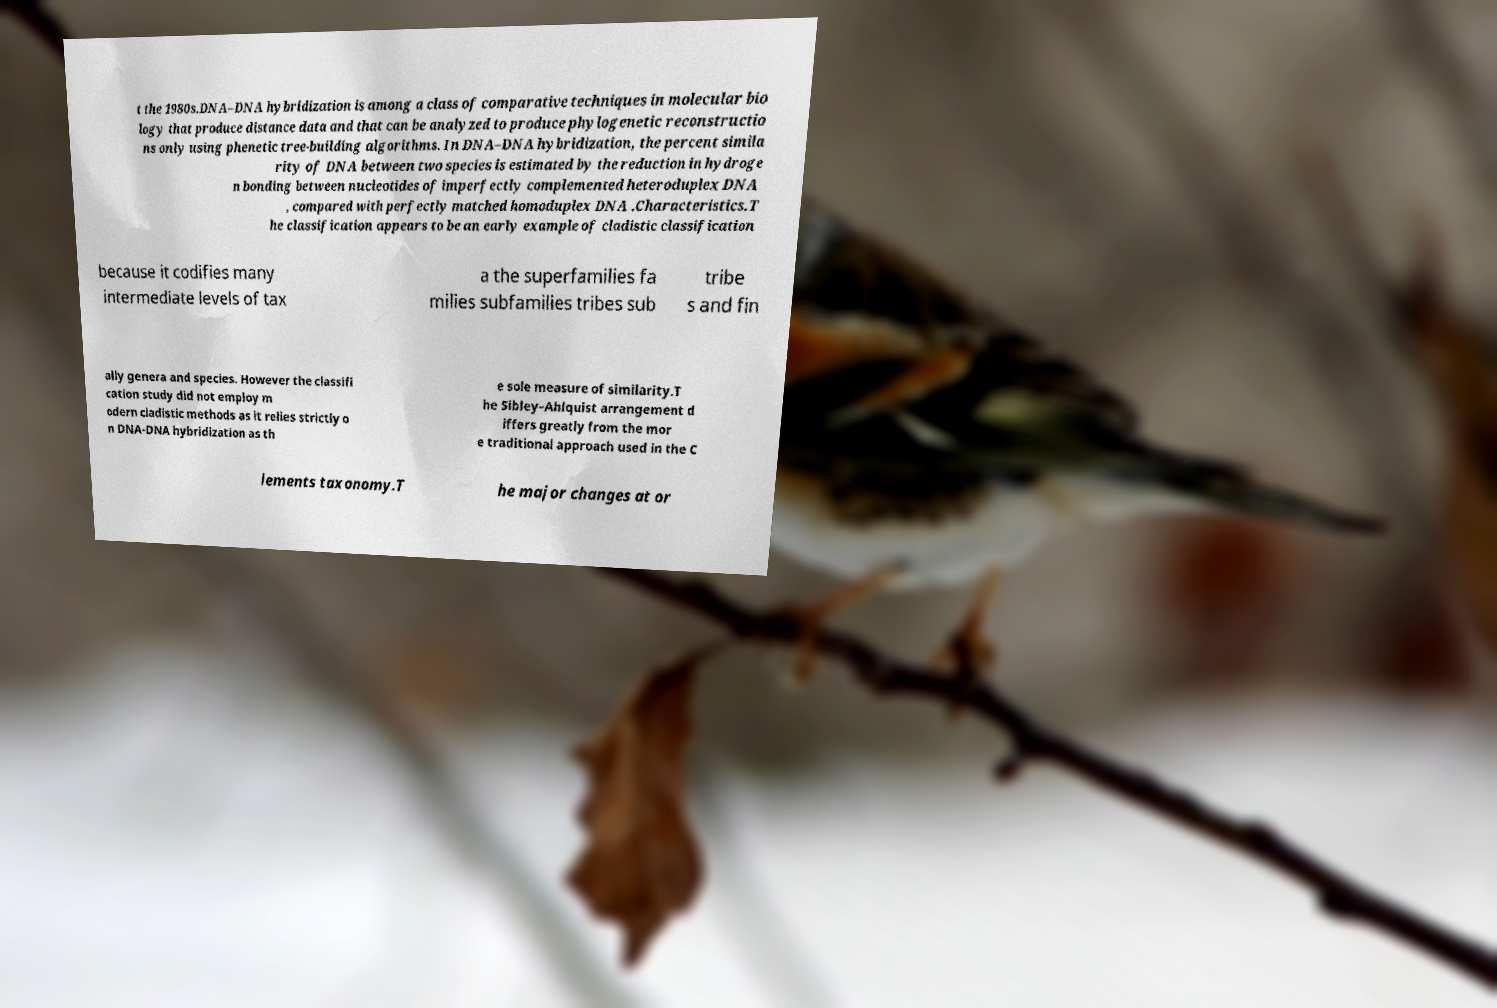I need the written content from this picture converted into text. Can you do that? t the 1980s.DNA–DNA hybridization is among a class of comparative techniques in molecular bio logy that produce distance data and that can be analyzed to produce phylogenetic reconstructio ns only using phenetic tree-building algorithms. In DNA–DNA hybridization, the percent simila rity of DNA between two species is estimated by the reduction in hydroge n bonding between nucleotides of imperfectly complemented heteroduplex DNA , compared with perfectly matched homoduplex DNA .Characteristics.T he classification appears to be an early example of cladistic classification because it codifies many intermediate levels of tax a the superfamilies fa milies subfamilies tribes sub tribe s and fin ally genera and species. However the classifi cation study did not employ m odern cladistic methods as it relies strictly o n DNA-DNA hybridization as th e sole measure of similarity.T he Sibley–Ahlquist arrangement d iffers greatly from the mor e traditional approach used in the C lements taxonomy.T he major changes at or 